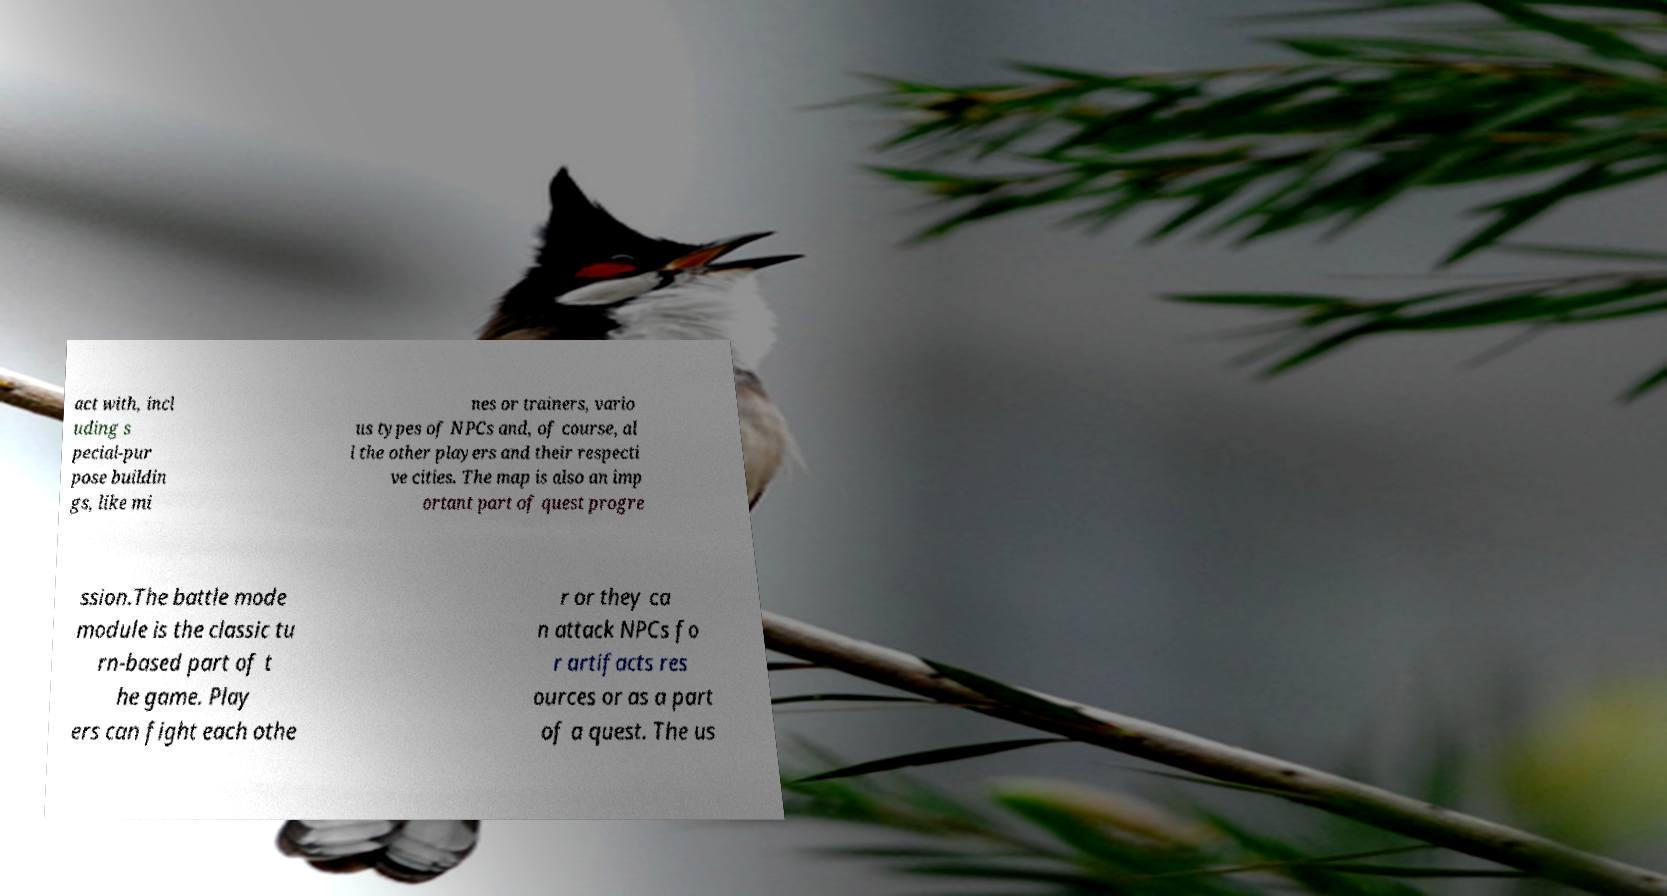I need the written content from this picture converted into text. Can you do that? act with, incl uding s pecial-pur pose buildin gs, like mi nes or trainers, vario us types of NPCs and, of course, al l the other players and their respecti ve cities. The map is also an imp ortant part of quest progre ssion.The battle mode module is the classic tu rn-based part of t he game. Play ers can fight each othe r or they ca n attack NPCs fo r artifacts res ources or as a part of a quest. The us 